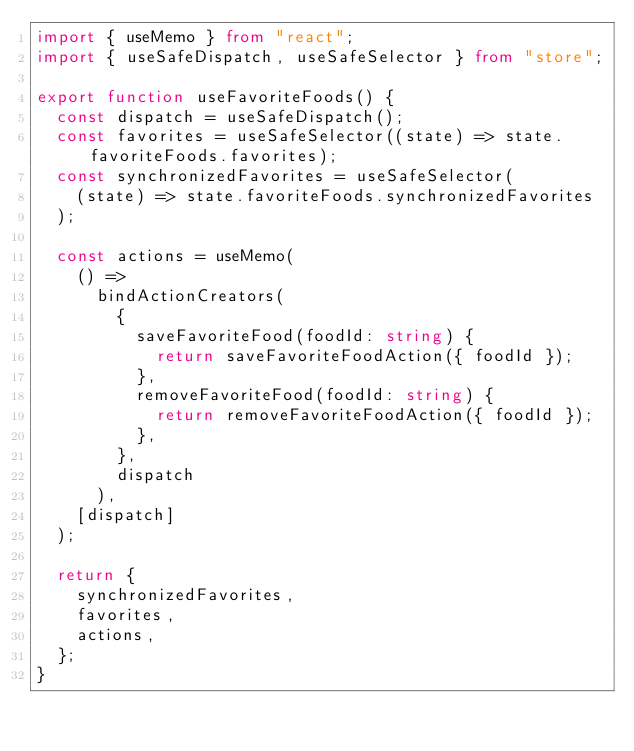<code> <loc_0><loc_0><loc_500><loc_500><_TypeScript_>import { useMemo } from "react";
import { useSafeDispatch, useSafeSelector } from "store";

export function useFavoriteFoods() {
  const dispatch = useSafeDispatch();
  const favorites = useSafeSelector((state) => state.favoriteFoods.favorites);
  const synchronizedFavorites = useSafeSelector(
    (state) => state.favoriteFoods.synchronizedFavorites
  );

  const actions = useMemo(
    () =>
      bindActionCreators(
        {
          saveFavoriteFood(foodId: string) {
            return saveFavoriteFoodAction({ foodId });
          },
          removeFavoriteFood(foodId: string) {
            return removeFavoriteFoodAction({ foodId });
          },
        },
        dispatch
      ),
    [dispatch]
  );

  return {
    synchronizedFavorites,
    favorites,
    actions,
  };
}
</code> 